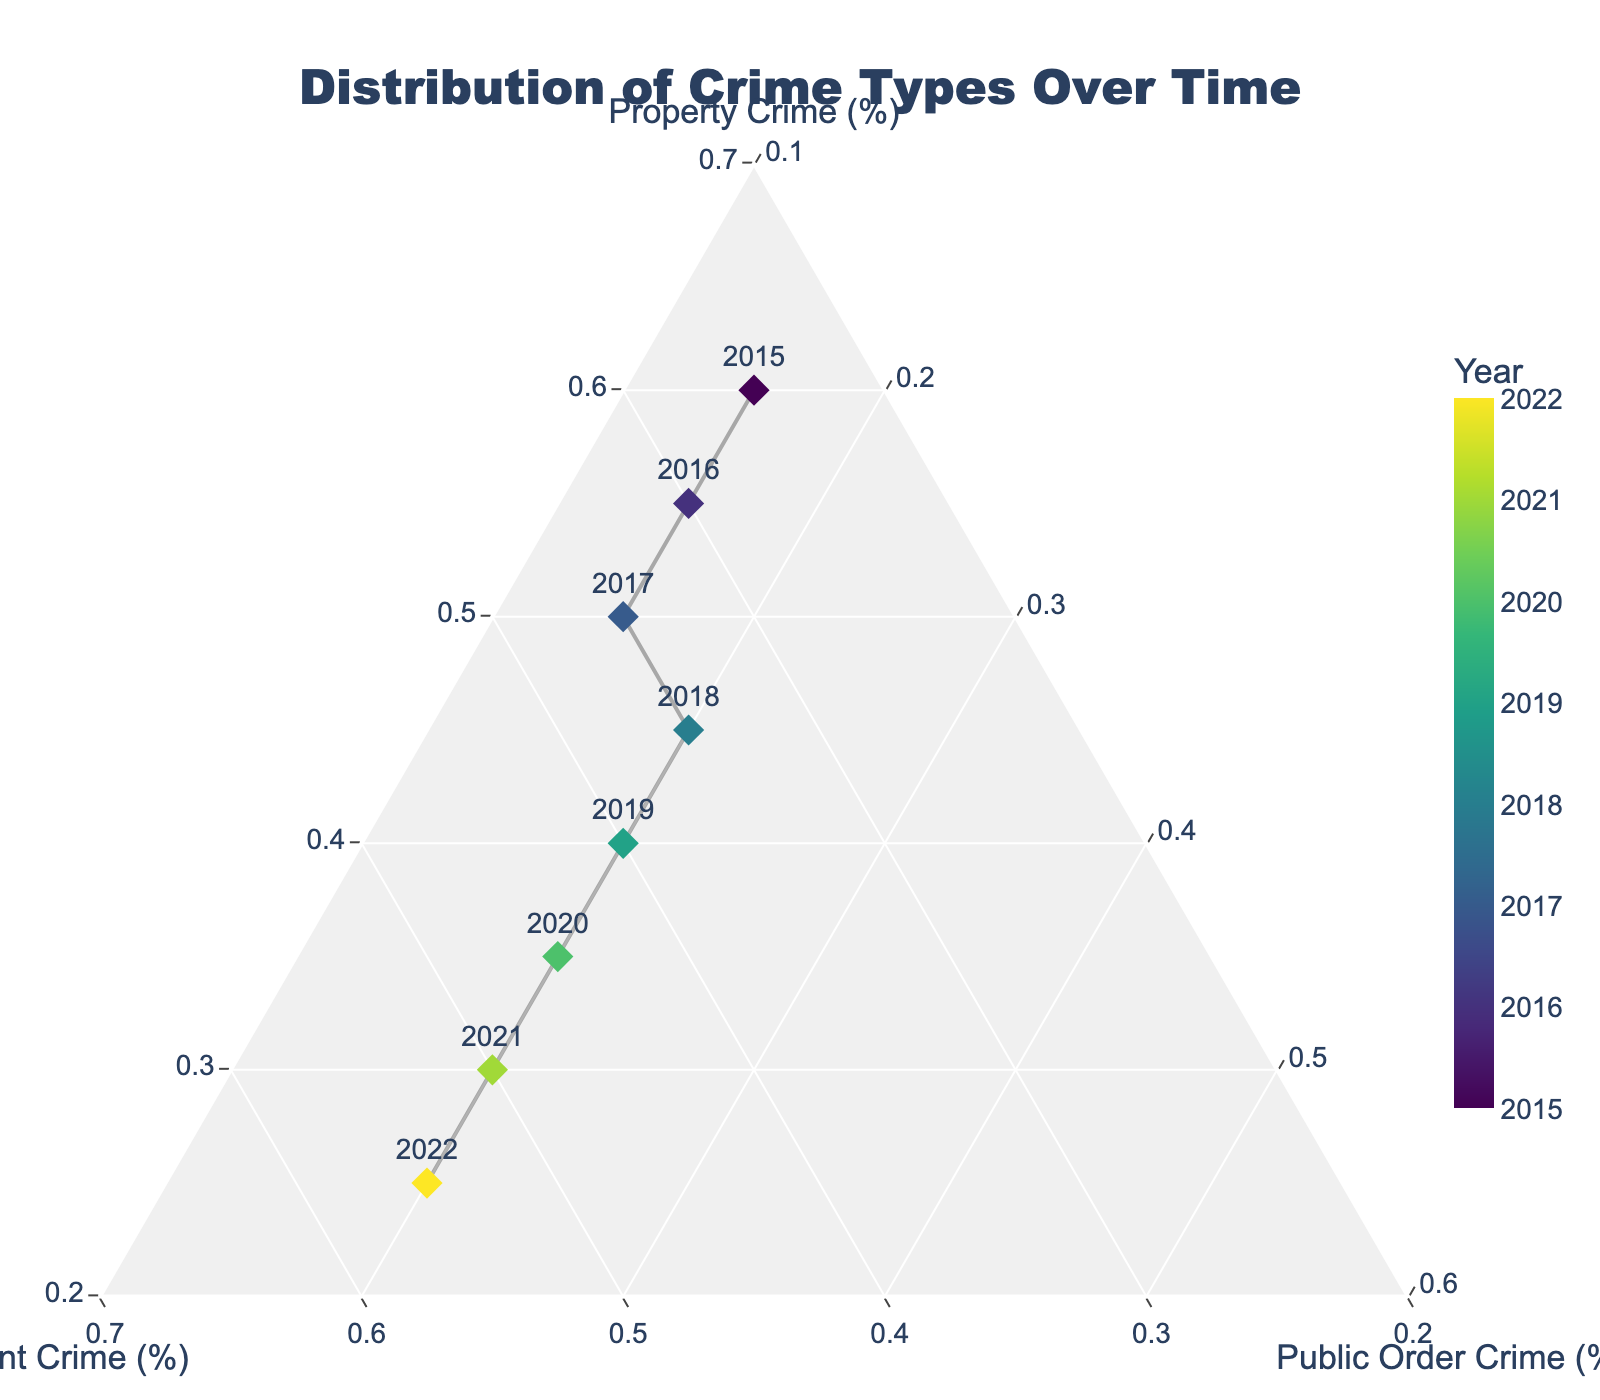What is the title of the figure? The title is typically displayed prominently at the top of the figure. It provides a summary of the content and purpose of the figure. In this case, it would be "Distribution of Crime Types Over Time," as stated in the code.
Answer: Distribution of Crime Types Over Time How does the proportion of Property Crime change over the years? Looking at the positions of the data points in the ternary plot, we can observe a gradual declining trend for Property Crime (%) as years progress from 2015 to 2022.
Answer: It decreases Which year has the highest percentage of Violent Crime? By checking the point with the highest b-axis (Violent Crime) value, we see that 2022 has the highest percentage of Violent Crime.
Answer: 2022 What year had the most balanced distribution across all three crime types? A balanced distribution would mean the point is closest to the center of the ternary plot, with roughly equal crime percentages. By visually identifying the closest point to the center, 2018 appears to be the most balanced.
Answer: 2018 Is the percentage of Public Order Crime constant over time? Observing the c-axis (Public Order Crime) values across all data points from 2015 to 2022, it is evident that the percentage remains around the same value, indicating constancy.
Answer: Yes In what year did Violent Crime surpass Property Crime for the first time? To answer this, we locate the first point where the percentage of Violent Crime on the b-axis is higher than that of Property Crime on the a-axis. This occurs in 2017.
Answer: 2017 How does the trend of Property Crime compare to that of Violent Crime over the years? The trend for Property Crime (%) consistently decreases over the years, whereas Violent Crime (%) consistently increases. Observing the points from 2015 to 2022 clearly shows this inverse relationship.
Answer: Property Crime decreases, Violent Crime increases 